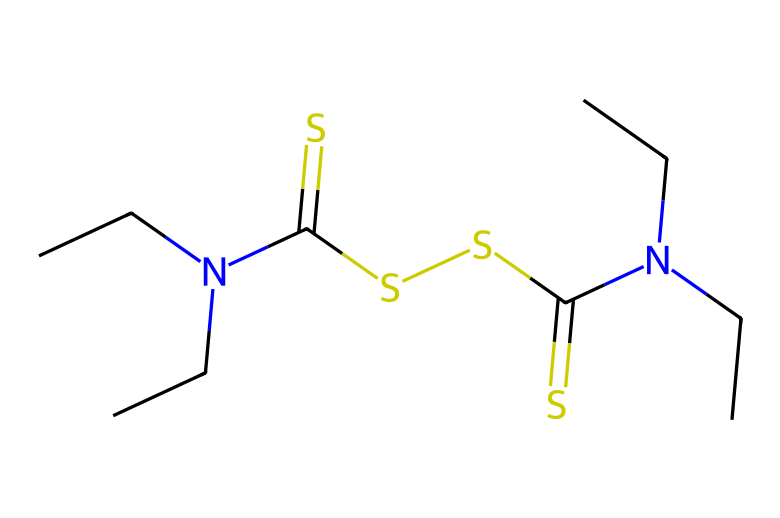What is the empirical formula of disulfiram? To find the empirical formula, we need to count the number of each type of atom in the SMILES representation. The structure shows Carbon (C), Nitrogen (N), and Sulfur (S) atoms. Counting them gives: C=10, H=18, N=2, S=4. The empirical formula is C10H18N2S4.
Answer: C10H18N2S4 How many sulfur atoms are present in disulfiram? Looking at the SMILES representation, we can identify the sulfur (S) atoms. There are four instances of sulfur in the structure.
Answer: 4 What functional groups are present in disulfiram? By analyzing the SMILES, we can identify functional groups such as the amine group (NH) linked to alkyl chains, and thioester-like groups due to the presence of sulfur. Both amine and thio functional groups are evident.
Answer: Amine and thio How many nitrogen atoms are present in disulfiram? In the SMILES, we count the presence of nitrogen (N) atoms. There are two nitrogen atoms located within the molecular structure.
Answer: 2 Does disulfiram contain any double bonds? We can analyze the SMILES for indications of double bonds, specifically looking for any '=' signs. There are two instances of double bonds between sulfur and carbon in disulfiram's structure.
Answer: Yes What is the primary purpose of disulfiram in addiction treatment? Disulfiram is primarily used to deter alcohol consumption by producing unpleasant effects when alcohol is ingested, thus supporting alcohol abstinence.
Answer: Alcohol deterrent 